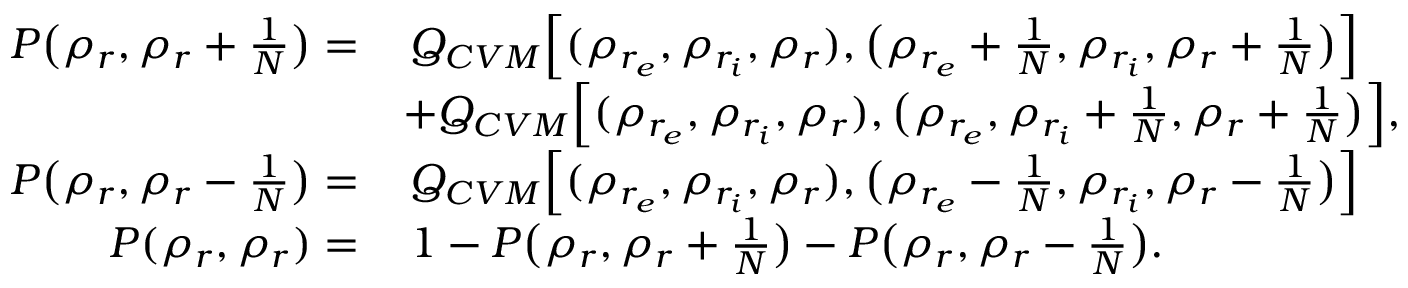<formula> <loc_0><loc_0><loc_500><loc_500>\begin{array} { r l } { P \left ( \rho _ { r } , \rho _ { r } + \frac { 1 } { N } \right ) = } & { \, Q _ { C V M } \left [ ( \rho _ { r _ { e } } , \rho _ { r _ { i } } , \rho _ { r } ) , \left ( \rho _ { r _ { e } } + \frac { 1 } { N } , \rho _ { r _ { i } } , \rho _ { r } + \frac { 1 } { N } \right ) \right ] } \\ & { + Q _ { C V M } \left [ ( \rho _ { r _ { e } } , \rho _ { r _ { i } } , \rho _ { r } ) , \left ( \rho _ { r _ { e } } , \rho _ { r _ { i } } + \frac { 1 } { N } , \rho _ { r } + \frac { 1 } { N } \right ) \right ] , } \\ { P \left ( \rho _ { r } , \rho _ { r } - \frac { 1 } { N } \right ) = } & { \, Q _ { C V M } \left [ ( \rho _ { r _ { e } } , \rho _ { r _ { i } } , \rho _ { r } ) , \left ( \rho _ { r _ { e } } - \frac { 1 } { N } , \rho _ { r _ { i } } , \rho _ { r } - \frac { 1 } { N } \right ) \right ] } \\ { P ( \rho _ { r } , \rho _ { r } ) = } & { \, 1 - P \left ( \rho _ { r } , \rho _ { r } + \frac { 1 } { N } \right ) - P \left ( \rho _ { r } , \rho _ { r } - \frac { 1 } { N } \right ) . } \end{array}</formula> 